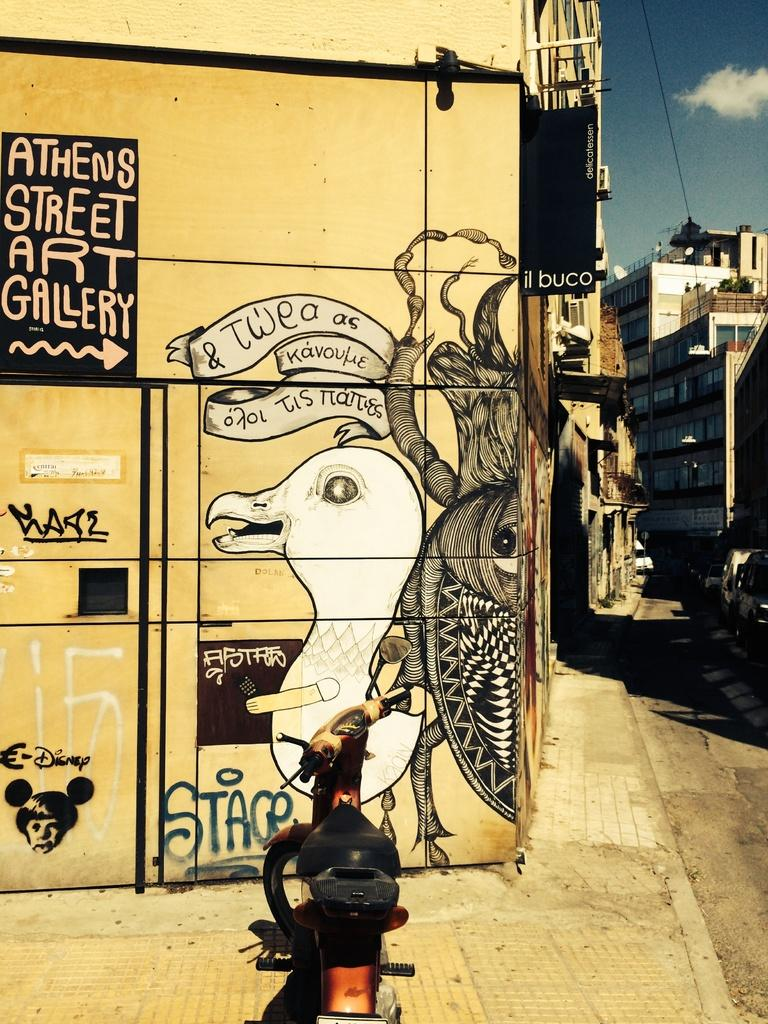<image>
Share a concise interpretation of the image provided. Wall full of grafitti as well as a word that says "Stage" on it. 